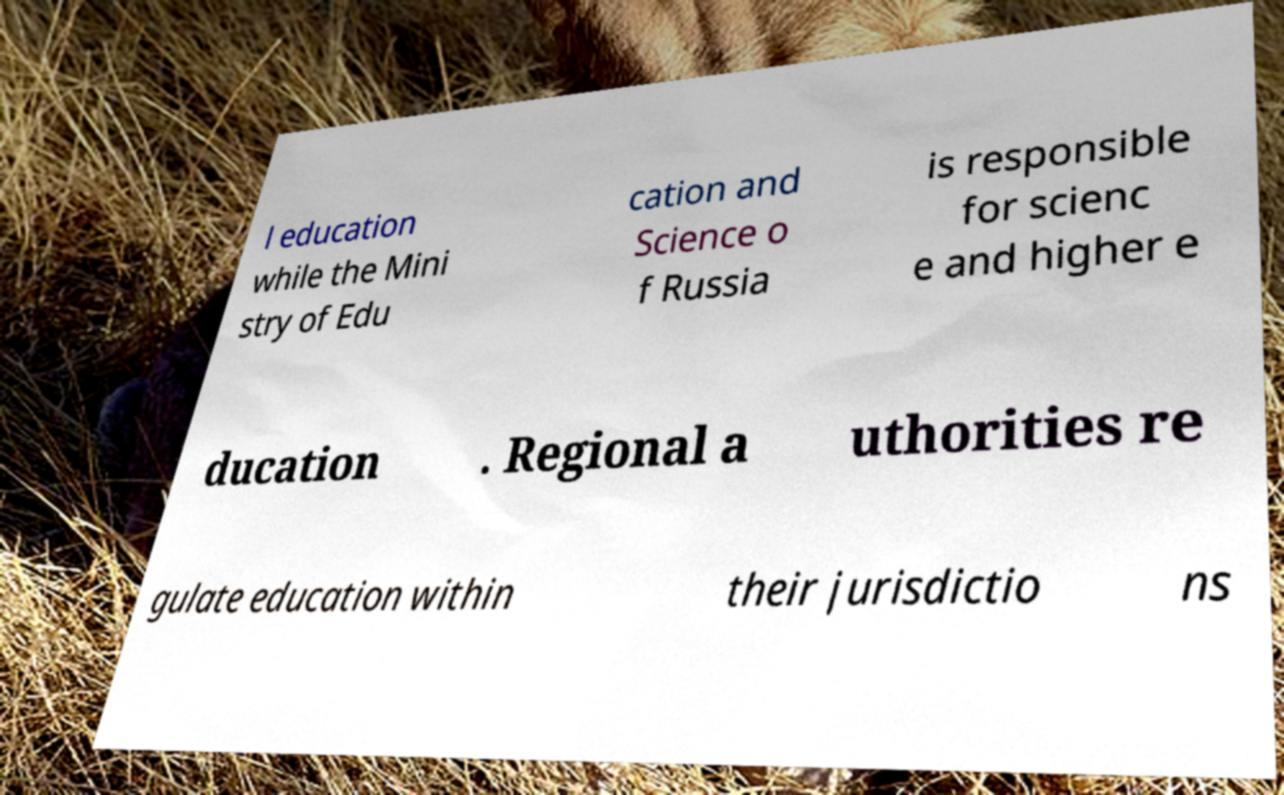Can you read and provide the text displayed in the image?This photo seems to have some interesting text. Can you extract and type it out for me? l education while the Mini stry of Edu cation and Science o f Russia is responsible for scienc e and higher e ducation . Regional a uthorities re gulate education within their jurisdictio ns 